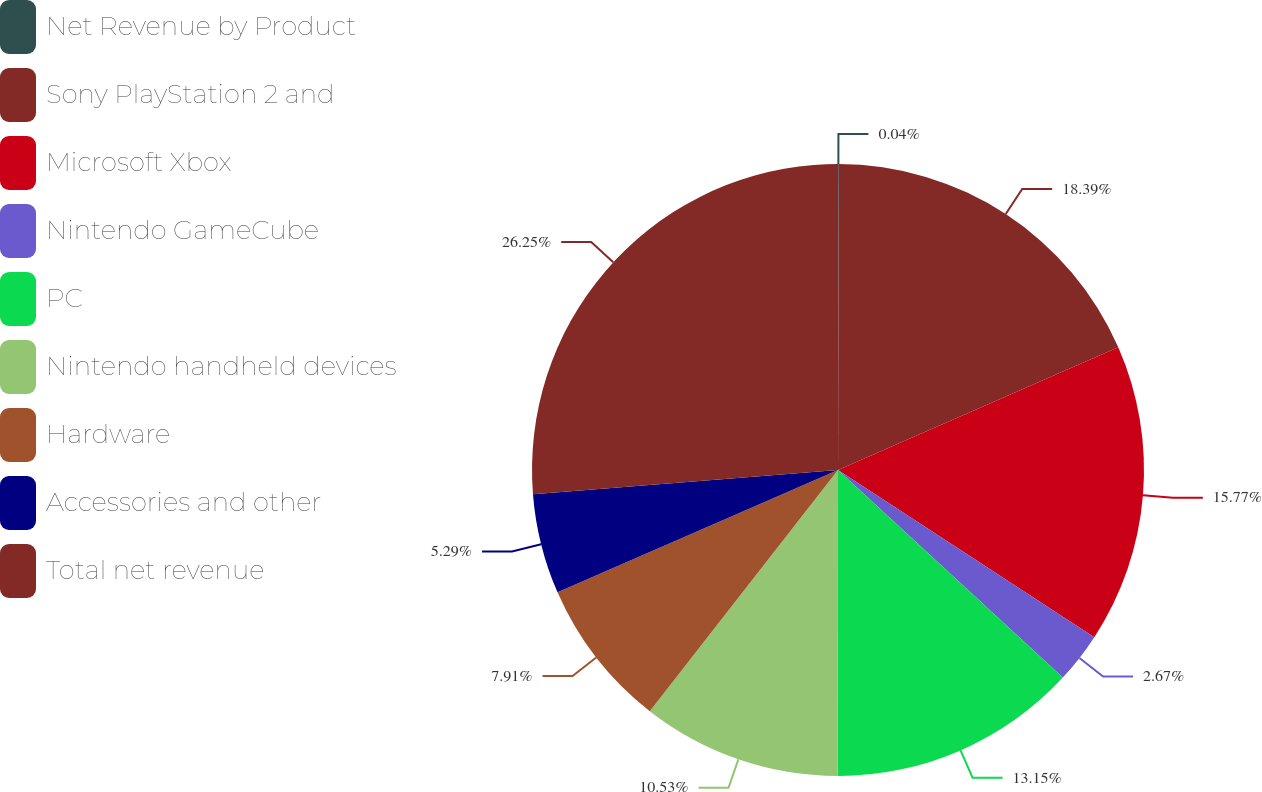<chart> <loc_0><loc_0><loc_500><loc_500><pie_chart><fcel>Net Revenue by Product<fcel>Sony PlayStation 2 and<fcel>Microsoft Xbox<fcel>Nintendo GameCube<fcel>PC<fcel>Nintendo handheld devices<fcel>Hardware<fcel>Accessories and other<fcel>Total net revenue<nl><fcel>0.04%<fcel>18.39%<fcel>15.77%<fcel>2.67%<fcel>13.15%<fcel>10.53%<fcel>7.91%<fcel>5.29%<fcel>26.26%<nl></chart> 